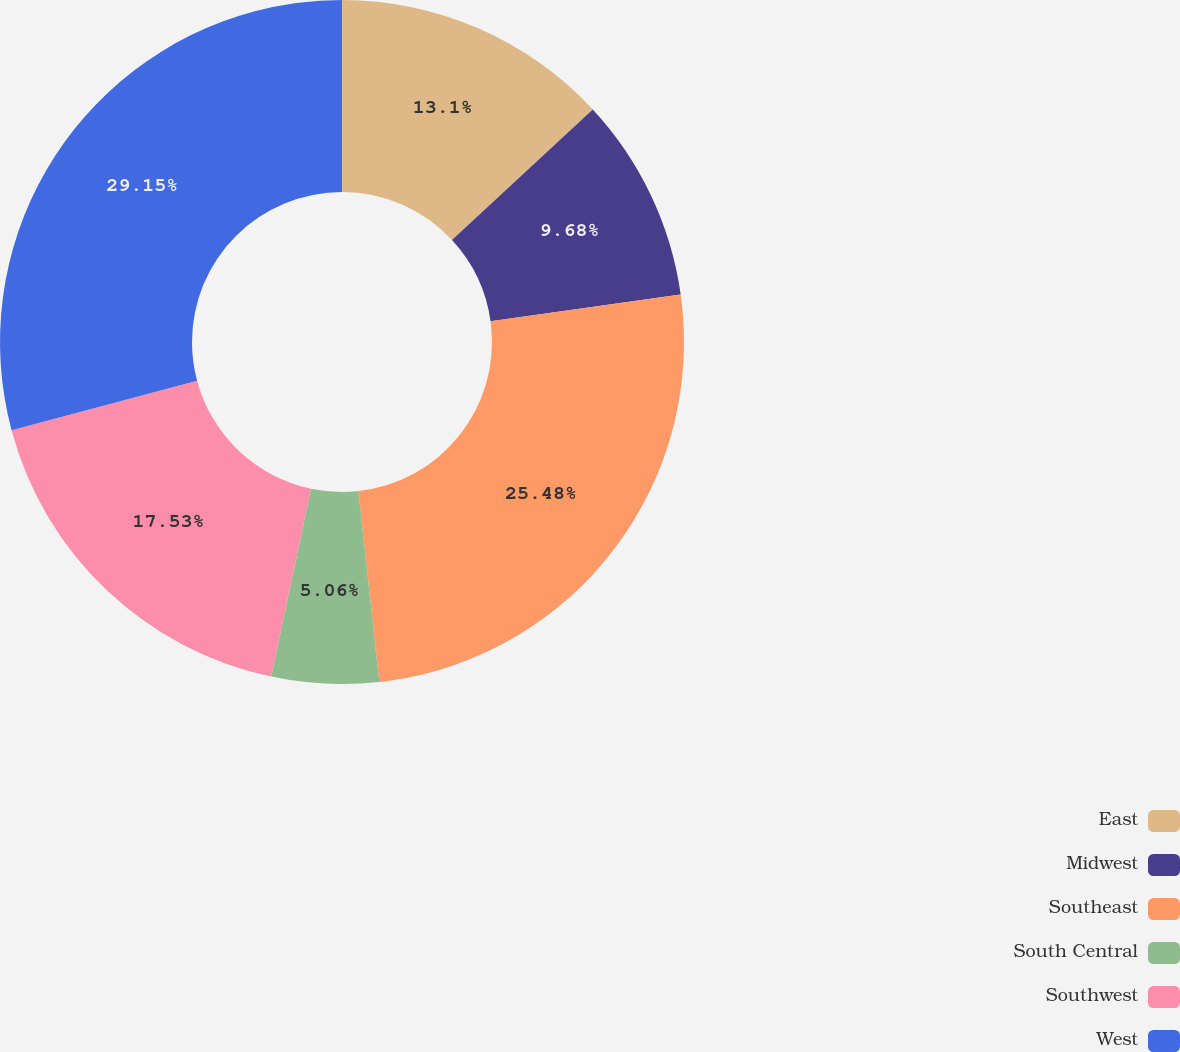Convert chart. <chart><loc_0><loc_0><loc_500><loc_500><pie_chart><fcel>East<fcel>Midwest<fcel>Southeast<fcel>South Central<fcel>Southwest<fcel>West<nl><fcel>13.1%<fcel>9.68%<fcel>25.48%<fcel>5.06%<fcel>17.53%<fcel>29.15%<nl></chart> 